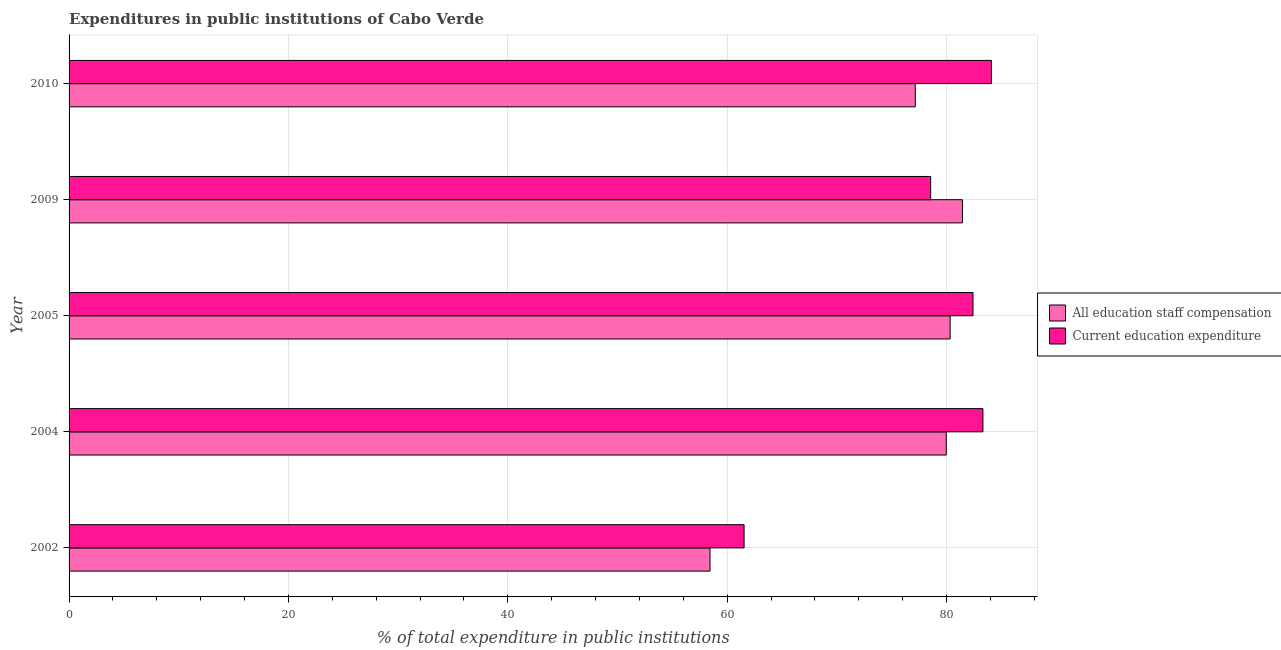Are the number of bars per tick equal to the number of legend labels?
Keep it short and to the point. Yes. Are the number of bars on each tick of the Y-axis equal?
Give a very brief answer. Yes. How many bars are there on the 2nd tick from the bottom?
Your answer should be compact. 2. In how many cases, is the number of bars for a given year not equal to the number of legend labels?
Give a very brief answer. 0. What is the expenditure in staff compensation in 2005?
Your answer should be very brief. 80.33. Across all years, what is the maximum expenditure in staff compensation?
Keep it short and to the point. 81.45. Across all years, what is the minimum expenditure in education?
Ensure brevity in your answer.  61.54. In which year was the expenditure in education minimum?
Keep it short and to the point. 2002. What is the total expenditure in staff compensation in the graph?
Ensure brevity in your answer.  377.33. What is the difference between the expenditure in education in 2004 and that in 2009?
Your response must be concise. 4.76. What is the difference between the expenditure in education in 2010 and the expenditure in staff compensation in 2002?
Your response must be concise. 25.66. What is the average expenditure in education per year?
Ensure brevity in your answer.  77.98. In the year 2010, what is the difference between the expenditure in education and expenditure in staff compensation?
Offer a terse response. 6.94. What is the ratio of the expenditure in education in 2002 to that in 2010?
Ensure brevity in your answer.  0.73. What is the difference between the highest and the second highest expenditure in education?
Keep it short and to the point. 0.77. What is the difference between the highest and the lowest expenditure in education?
Make the answer very short. 22.55. In how many years, is the expenditure in staff compensation greater than the average expenditure in staff compensation taken over all years?
Offer a very short reply. 4. What does the 2nd bar from the top in 2009 represents?
Keep it short and to the point. All education staff compensation. What does the 1st bar from the bottom in 2010 represents?
Offer a very short reply. All education staff compensation. How many bars are there?
Ensure brevity in your answer.  10. Are the values on the major ticks of X-axis written in scientific E-notation?
Provide a short and direct response. No. How many legend labels are there?
Your answer should be compact. 2. What is the title of the graph?
Your answer should be compact. Expenditures in public institutions of Cabo Verde. Does "Arms imports" appear as one of the legend labels in the graph?
Ensure brevity in your answer.  No. What is the label or title of the X-axis?
Make the answer very short. % of total expenditure in public institutions. What is the % of total expenditure in public institutions of All education staff compensation in 2002?
Provide a short and direct response. 58.43. What is the % of total expenditure in public institutions of Current education expenditure in 2002?
Your response must be concise. 61.54. What is the % of total expenditure in public institutions in All education staff compensation in 2004?
Ensure brevity in your answer.  79.97. What is the % of total expenditure in public institutions of Current education expenditure in 2004?
Your answer should be compact. 83.31. What is the % of total expenditure in public institutions of All education staff compensation in 2005?
Your answer should be compact. 80.33. What is the % of total expenditure in public institutions of Current education expenditure in 2005?
Offer a terse response. 82.41. What is the % of total expenditure in public institutions in All education staff compensation in 2009?
Offer a very short reply. 81.45. What is the % of total expenditure in public institutions of Current education expenditure in 2009?
Your response must be concise. 78.55. What is the % of total expenditure in public institutions of All education staff compensation in 2010?
Your response must be concise. 77.15. What is the % of total expenditure in public institutions in Current education expenditure in 2010?
Keep it short and to the point. 84.09. Across all years, what is the maximum % of total expenditure in public institutions of All education staff compensation?
Offer a very short reply. 81.45. Across all years, what is the maximum % of total expenditure in public institutions of Current education expenditure?
Keep it short and to the point. 84.09. Across all years, what is the minimum % of total expenditure in public institutions of All education staff compensation?
Provide a succinct answer. 58.43. Across all years, what is the minimum % of total expenditure in public institutions in Current education expenditure?
Your answer should be compact. 61.54. What is the total % of total expenditure in public institutions of All education staff compensation in the graph?
Provide a short and direct response. 377.33. What is the total % of total expenditure in public institutions in Current education expenditure in the graph?
Make the answer very short. 389.9. What is the difference between the % of total expenditure in public institutions in All education staff compensation in 2002 and that in 2004?
Provide a short and direct response. -21.54. What is the difference between the % of total expenditure in public institutions in Current education expenditure in 2002 and that in 2004?
Your response must be concise. -21.78. What is the difference between the % of total expenditure in public institutions in All education staff compensation in 2002 and that in 2005?
Your answer should be compact. -21.89. What is the difference between the % of total expenditure in public institutions in Current education expenditure in 2002 and that in 2005?
Your answer should be compact. -20.87. What is the difference between the % of total expenditure in public institutions in All education staff compensation in 2002 and that in 2009?
Make the answer very short. -23.02. What is the difference between the % of total expenditure in public institutions in Current education expenditure in 2002 and that in 2009?
Make the answer very short. -17.01. What is the difference between the % of total expenditure in public institutions of All education staff compensation in 2002 and that in 2010?
Give a very brief answer. -18.72. What is the difference between the % of total expenditure in public institutions in Current education expenditure in 2002 and that in 2010?
Your answer should be compact. -22.55. What is the difference between the % of total expenditure in public institutions in All education staff compensation in 2004 and that in 2005?
Keep it short and to the point. -0.35. What is the difference between the % of total expenditure in public institutions of Current education expenditure in 2004 and that in 2005?
Ensure brevity in your answer.  0.9. What is the difference between the % of total expenditure in public institutions of All education staff compensation in 2004 and that in 2009?
Your response must be concise. -1.47. What is the difference between the % of total expenditure in public institutions in Current education expenditure in 2004 and that in 2009?
Your response must be concise. 4.76. What is the difference between the % of total expenditure in public institutions of All education staff compensation in 2004 and that in 2010?
Ensure brevity in your answer.  2.83. What is the difference between the % of total expenditure in public institutions of Current education expenditure in 2004 and that in 2010?
Make the answer very short. -0.77. What is the difference between the % of total expenditure in public institutions in All education staff compensation in 2005 and that in 2009?
Offer a very short reply. -1.12. What is the difference between the % of total expenditure in public institutions of Current education expenditure in 2005 and that in 2009?
Offer a very short reply. 3.86. What is the difference between the % of total expenditure in public institutions of All education staff compensation in 2005 and that in 2010?
Keep it short and to the point. 3.18. What is the difference between the % of total expenditure in public institutions in Current education expenditure in 2005 and that in 2010?
Your answer should be compact. -1.68. What is the difference between the % of total expenditure in public institutions of All education staff compensation in 2009 and that in 2010?
Make the answer very short. 4.3. What is the difference between the % of total expenditure in public institutions of Current education expenditure in 2009 and that in 2010?
Provide a succinct answer. -5.54. What is the difference between the % of total expenditure in public institutions in All education staff compensation in 2002 and the % of total expenditure in public institutions in Current education expenditure in 2004?
Provide a short and direct response. -24.88. What is the difference between the % of total expenditure in public institutions of All education staff compensation in 2002 and the % of total expenditure in public institutions of Current education expenditure in 2005?
Provide a succinct answer. -23.98. What is the difference between the % of total expenditure in public institutions of All education staff compensation in 2002 and the % of total expenditure in public institutions of Current education expenditure in 2009?
Your response must be concise. -20.12. What is the difference between the % of total expenditure in public institutions of All education staff compensation in 2002 and the % of total expenditure in public institutions of Current education expenditure in 2010?
Provide a succinct answer. -25.66. What is the difference between the % of total expenditure in public institutions of All education staff compensation in 2004 and the % of total expenditure in public institutions of Current education expenditure in 2005?
Provide a short and direct response. -2.44. What is the difference between the % of total expenditure in public institutions in All education staff compensation in 2004 and the % of total expenditure in public institutions in Current education expenditure in 2009?
Provide a succinct answer. 1.42. What is the difference between the % of total expenditure in public institutions in All education staff compensation in 2004 and the % of total expenditure in public institutions in Current education expenditure in 2010?
Your answer should be very brief. -4.11. What is the difference between the % of total expenditure in public institutions of All education staff compensation in 2005 and the % of total expenditure in public institutions of Current education expenditure in 2009?
Your answer should be very brief. 1.78. What is the difference between the % of total expenditure in public institutions of All education staff compensation in 2005 and the % of total expenditure in public institutions of Current education expenditure in 2010?
Make the answer very short. -3.76. What is the difference between the % of total expenditure in public institutions in All education staff compensation in 2009 and the % of total expenditure in public institutions in Current education expenditure in 2010?
Give a very brief answer. -2.64. What is the average % of total expenditure in public institutions of All education staff compensation per year?
Provide a succinct answer. 75.47. What is the average % of total expenditure in public institutions of Current education expenditure per year?
Provide a short and direct response. 77.98. In the year 2002, what is the difference between the % of total expenditure in public institutions of All education staff compensation and % of total expenditure in public institutions of Current education expenditure?
Provide a short and direct response. -3.11. In the year 2004, what is the difference between the % of total expenditure in public institutions in All education staff compensation and % of total expenditure in public institutions in Current education expenditure?
Provide a succinct answer. -3.34. In the year 2005, what is the difference between the % of total expenditure in public institutions in All education staff compensation and % of total expenditure in public institutions in Current education expenditure?
Offer a very short reply. -2.08. In the year 2009, what is the difference between the % of total expenditure in public institutions in All education staff compensation and % of total expenditure in public institutions in Current education expenditure?
Provide a short and direct response. 2.9. In the year 2010, what is the difference between the % of total expenditure in public institutions in All education staff compensation and % of total expenditure in public institutions in Current education expenditure?
Offer a terse response. -6.94. What is the ratio of the % of total expenditure in public institutions of All education staff compensation in 2002 to that in 2004?
Offer a very short reply. 0.73. What is the ratio of the % of total expenditure in public institutions of Current education expenditure in 2002 to that in 2004?
Keep it short and to the point. 0.74. What is the ratio of the % of total expenditure in public institutions in All education staff compensation in 2002 to that in 2005?
Provide a succinct answer. 0.73. What is the ratio of the % of total expenditure in public institutions in Current education expenditure in 2002 to that in 2005?
Provide a succinct answer. 0.75. What is the ratio of the % of total expenditure in public institutions of All education staff compensation in 2002 to that in 2009?
Your answer should be very brief. 0.72. What is the ratio of the % of total expenditure in public institutions in Current education expenditure in 2002 to that in 2009?
Provide a short and direct response. 0.78. What is the ratio of the % of total expenditure in public institutions in All education staff compensation in 2002 to that in 2010?
Give a very brief answer. 0.76. What is the ratio of the % of total expenditure in public institutions in Current education expenditure in 2002 to that in 2010?
Offer a very short reply. 0.73. What is the ratio of the % of total expenditure in public institutions of All education staff compensation in 2004 to that in 2009?
Offer a terse response. 0.98. What is the ratio of the % of total expenditure in public institutions in Current education expenditure in 2004 to that in 2009?
Give a very brief answer. 1.06. What is the ratio of the % of total expenditure in public institutions of All education staff compensation in 2004 to that in 2010?
Your answer should be compact. 1.04. What is the ratio of the % of total expenditure in public institutions in All education staff compensation in 2005 to that in 2009?
Your answer should be very brief. 0.99. What is the ratio of the % of total expenditure in public institutions of Current education expenditure in 2005 to that in 2009?
Make the answer very short. 1.05. What is the ratio of the % of total expenditure in public institutions in All education staff compensation in 2005 to that in 2010?
Your response must be concise. 1.04. What is the ratio of the % of total expenditure in public institutions in Current education expenditure in 2005 to that in 2010?
Your answer should be compact. 0.98. What is the ratio of the % of total expenditure in public institutions of All education staff compensation in 2009 to that in 2010?
Offer a very short reply. 1.06. What is the ratio of the % of total expenditure in public institutions in Current education expenditure in 2009 to that in 2010?
Provide a succinct answer. 0.93. What is the difference between the highest and the second highest % of total expenditure in public institutions of All education staff compensation?
Give a very brief answer. 1.12. What is the difference between the highest and the second highest % of total expenditure in public institutions in Current education expenditure?
Offer a very short reply. 0.77. What is the difference between the highest and the lowest % of total expenditure in public institutions in All education staff compensation?
Make the answer very short. 23.02. What is the difference between the highest and the lowest % of total expenditure in public institutions of Current education expenditure?
Your answer should be compact. 22.55. 